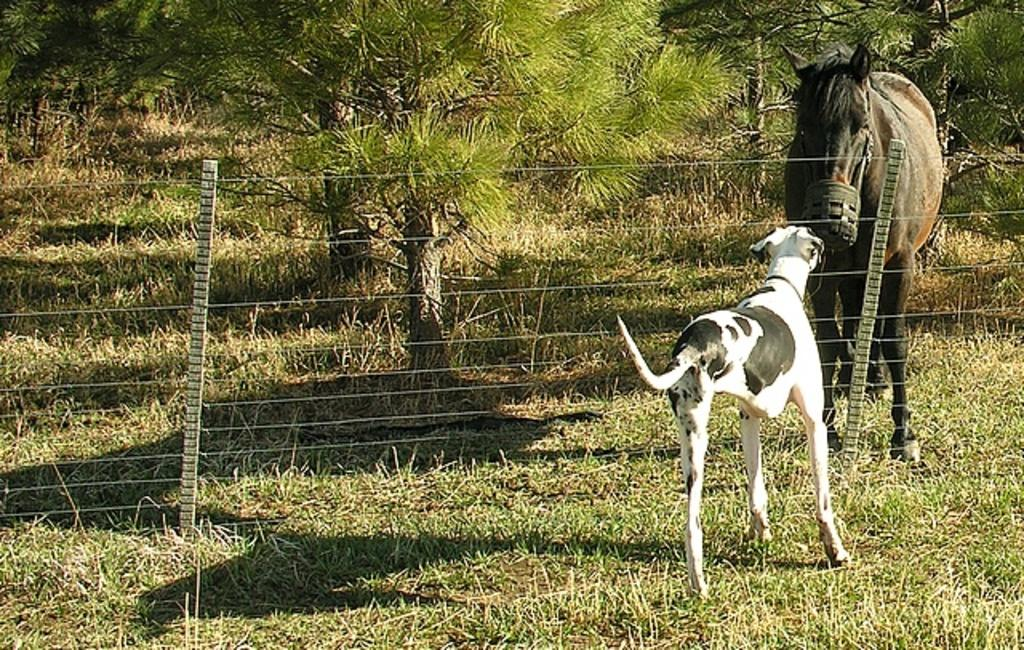What type of animals can be seen in the image? There are animals on the ground in the image. What can be seen in the background of the image? There are trees visible in the background of the image. What color is the pencil used by the animals to draw in the image? There is no pencil present in the image, and the animals are not shown drawing. 